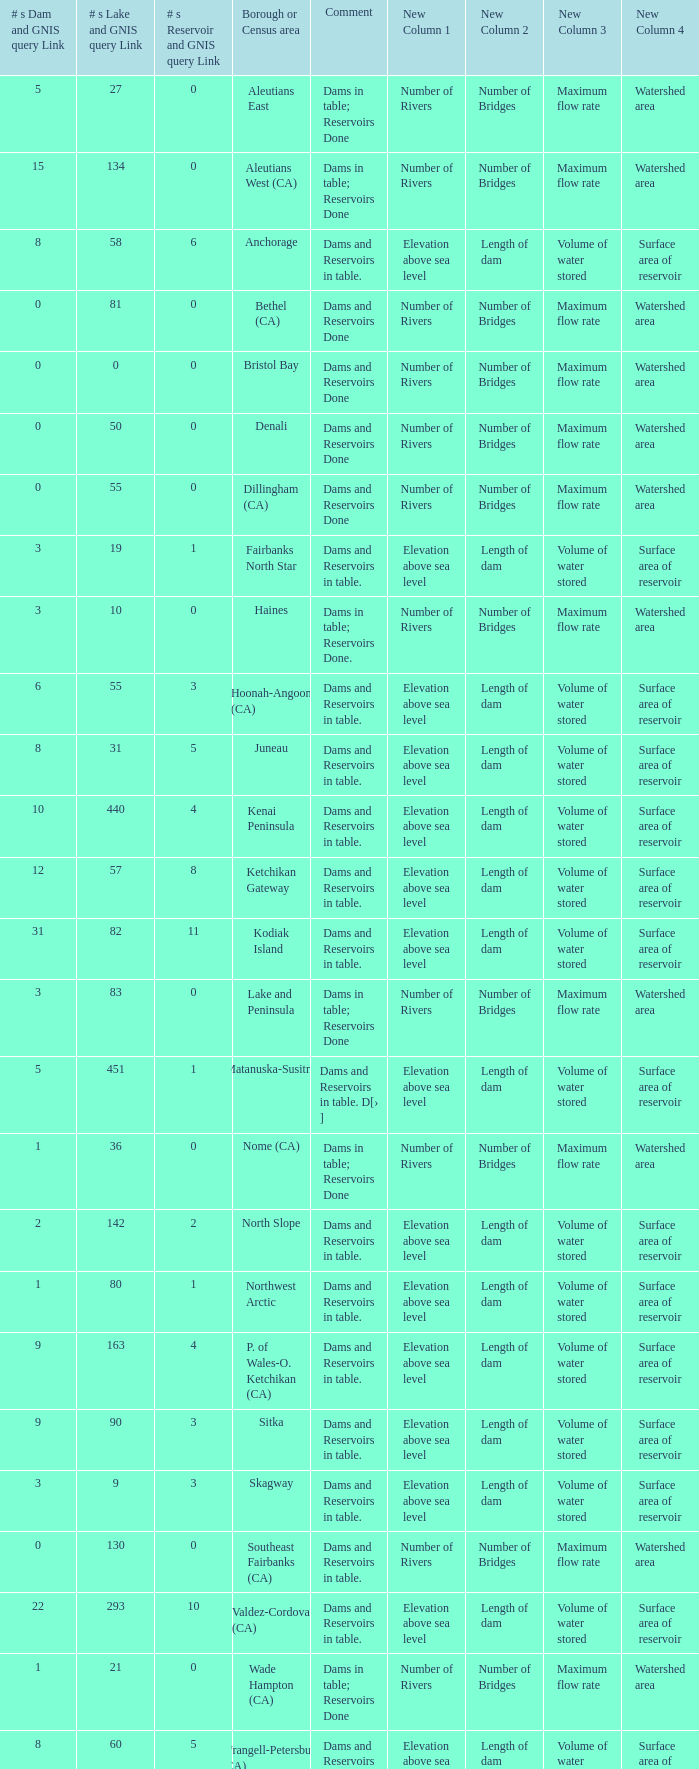Name the minimum number of reservoir for gnis query link where numbers lake gnis query link being 60 5.0. 